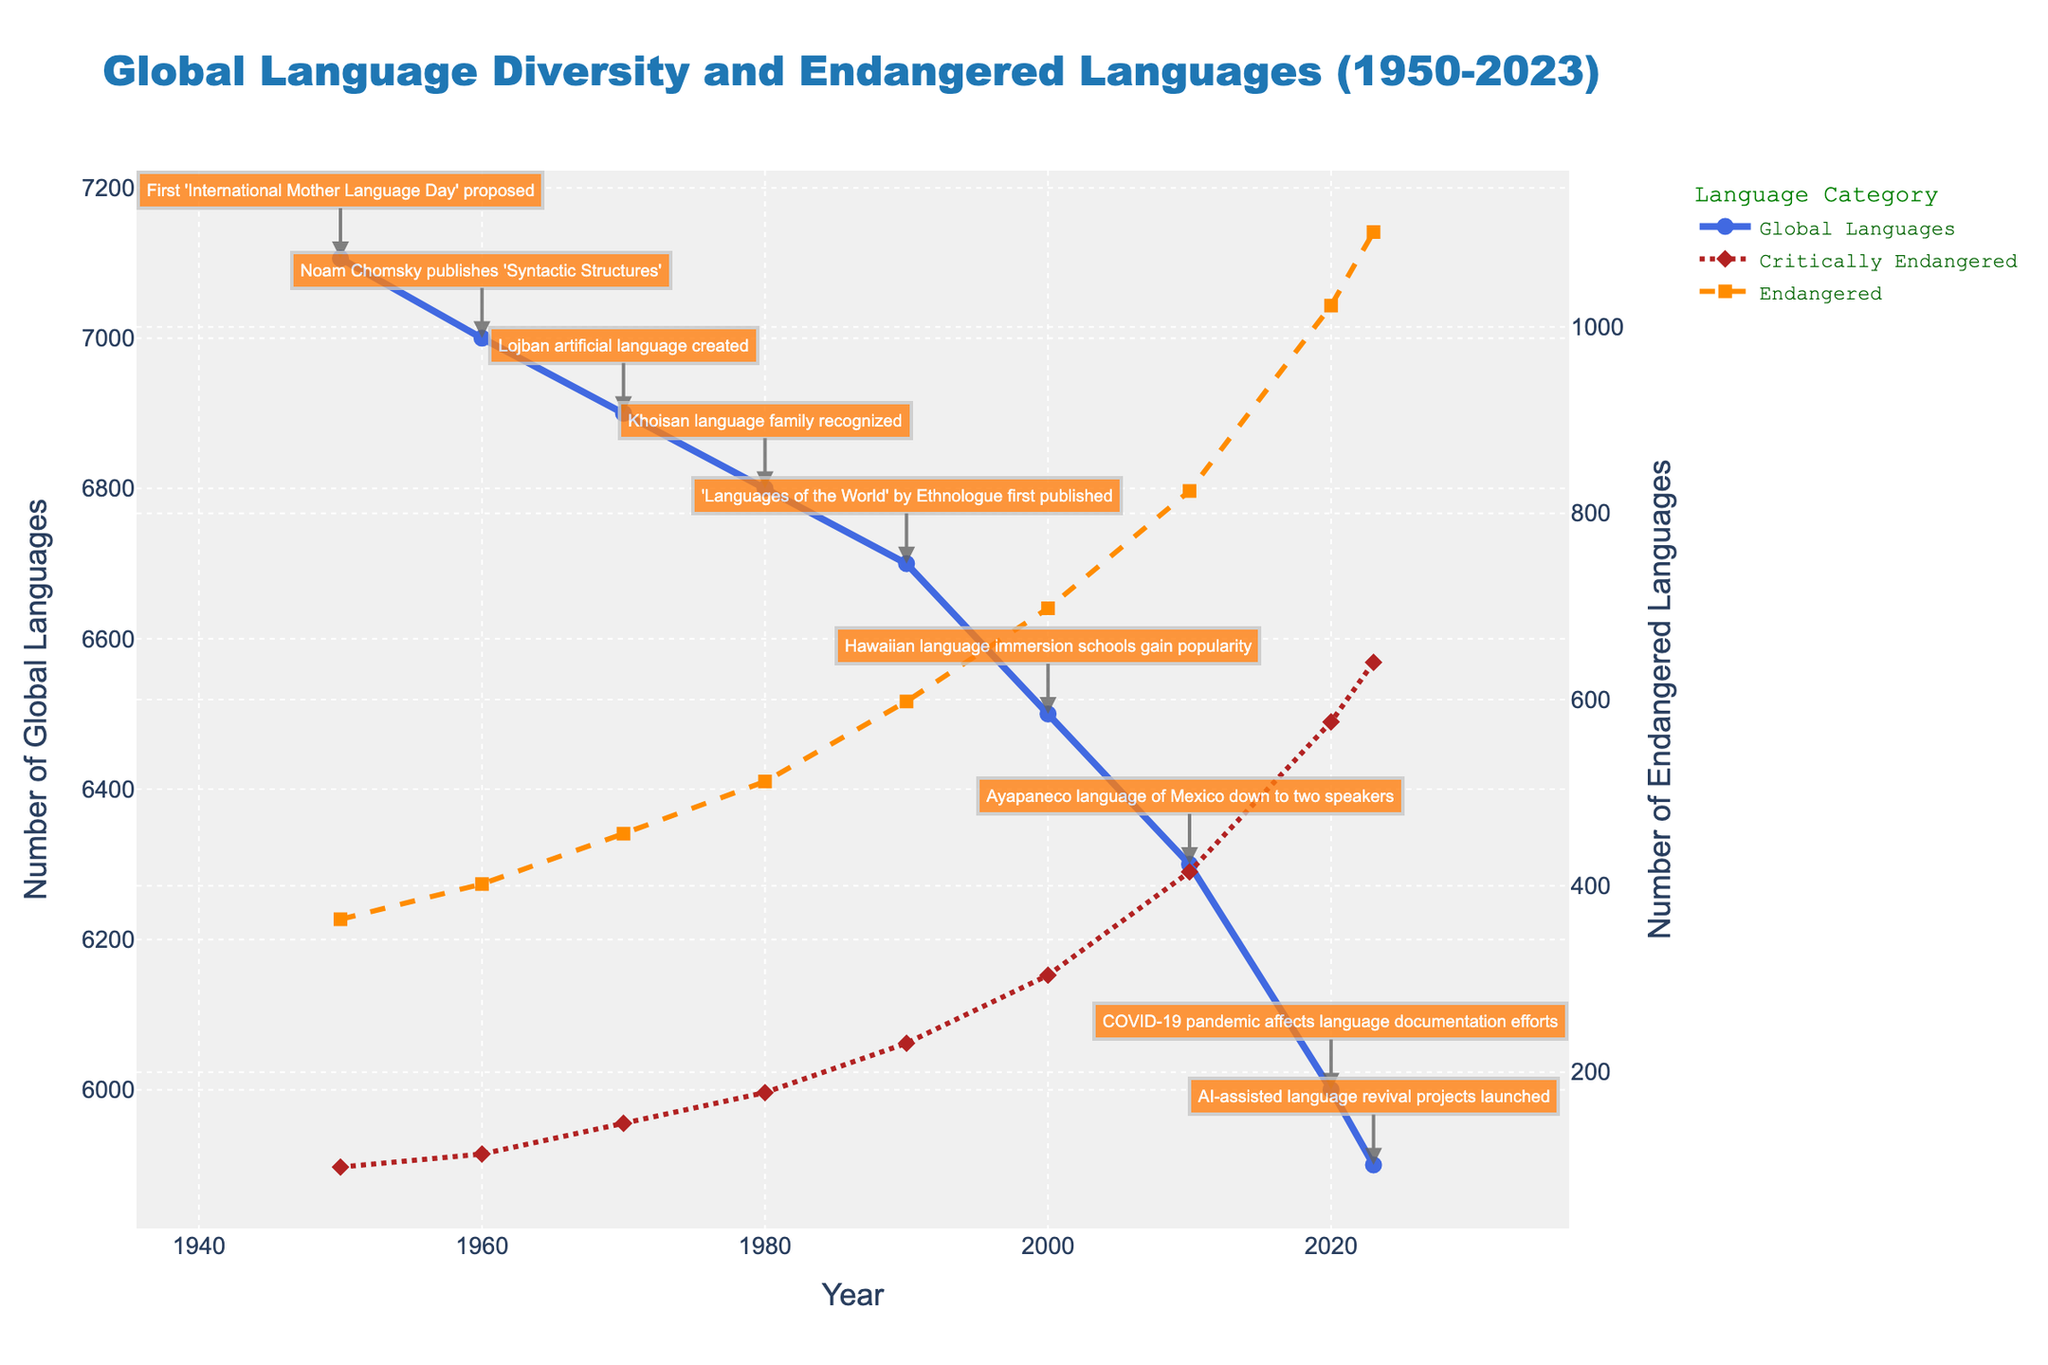What was the trend in the number of estimated global languages from 1950 to 2023? The trend saw a steady decline in the number of estimated global languages from 7106 in 1950 to 5900 in 2023, illustrating a decrease in language diversity over the years.
Answer: Decline By how much did the number of critically endangered languages increase between 2000 and 2023? The number of critically endangered languages was 304 in 2000 and increased to 640 in 2023. The difference is 640 - 304 = 336.
Answer: 336 Compare the rate of increase in critically endangered languages and endangered languages from 1950 to 2020. Which category increased more? Critically endangered languages increased from 98 in 1950 to 576 in 2020, a change of 478. Endangered languages increased from 364 in 1950 to 1023 in 2020, a change of 659. Thus, endangered languages increased more.
Answer: Endangered languages What was the number of endangered languages in 1980, and how does that compare to the number of critically endangered languages in the same year? In 1980, there were 512 endangered languages and 178 critically endangered languages. Comparing these numbers, there were 334 more endangered languages than critically endangered languages.
Answer: 334 more In which year did the number of critically endangered languages surpass 400? The number of critically endangered languages first surpassed 400 in the year 2010, reaching 415.
Answer: 2010 What is the overall percentage decline in the number of estimated global languages from 1950 to 2023? The number of estimated global languages in 1950 was 7106, and in 2023 it was 5900. The percentage decline is calculated as ((7106 - 5900) / 7106) * 100 = 16.96%.
Answer: 16.96% Visually, which line (color and style) represents the category of endangered languages in the plot? The endangered languages are represented by a dark orange dashed line in the plot.
Answer: Dark orange dashed line From the visual cues, how does the number of total estimated global languages in 1990 compare to the number in 2023? The number of estimated global languages decreased from around 6700 in 1990 to about 5900 in 2023. The total number is smaller in 2023.
Answer: Smaller in 2023 How did the critically endangered languages' trend behave from 1950 to 2023? Was it steady or fluctuating? The trend for critically endangered languages from 1950 to 2023 was steadily increasing, without significant fluctuations, indicating a continuous rise in critically endangered languages.
Answer: Steadily increasing 